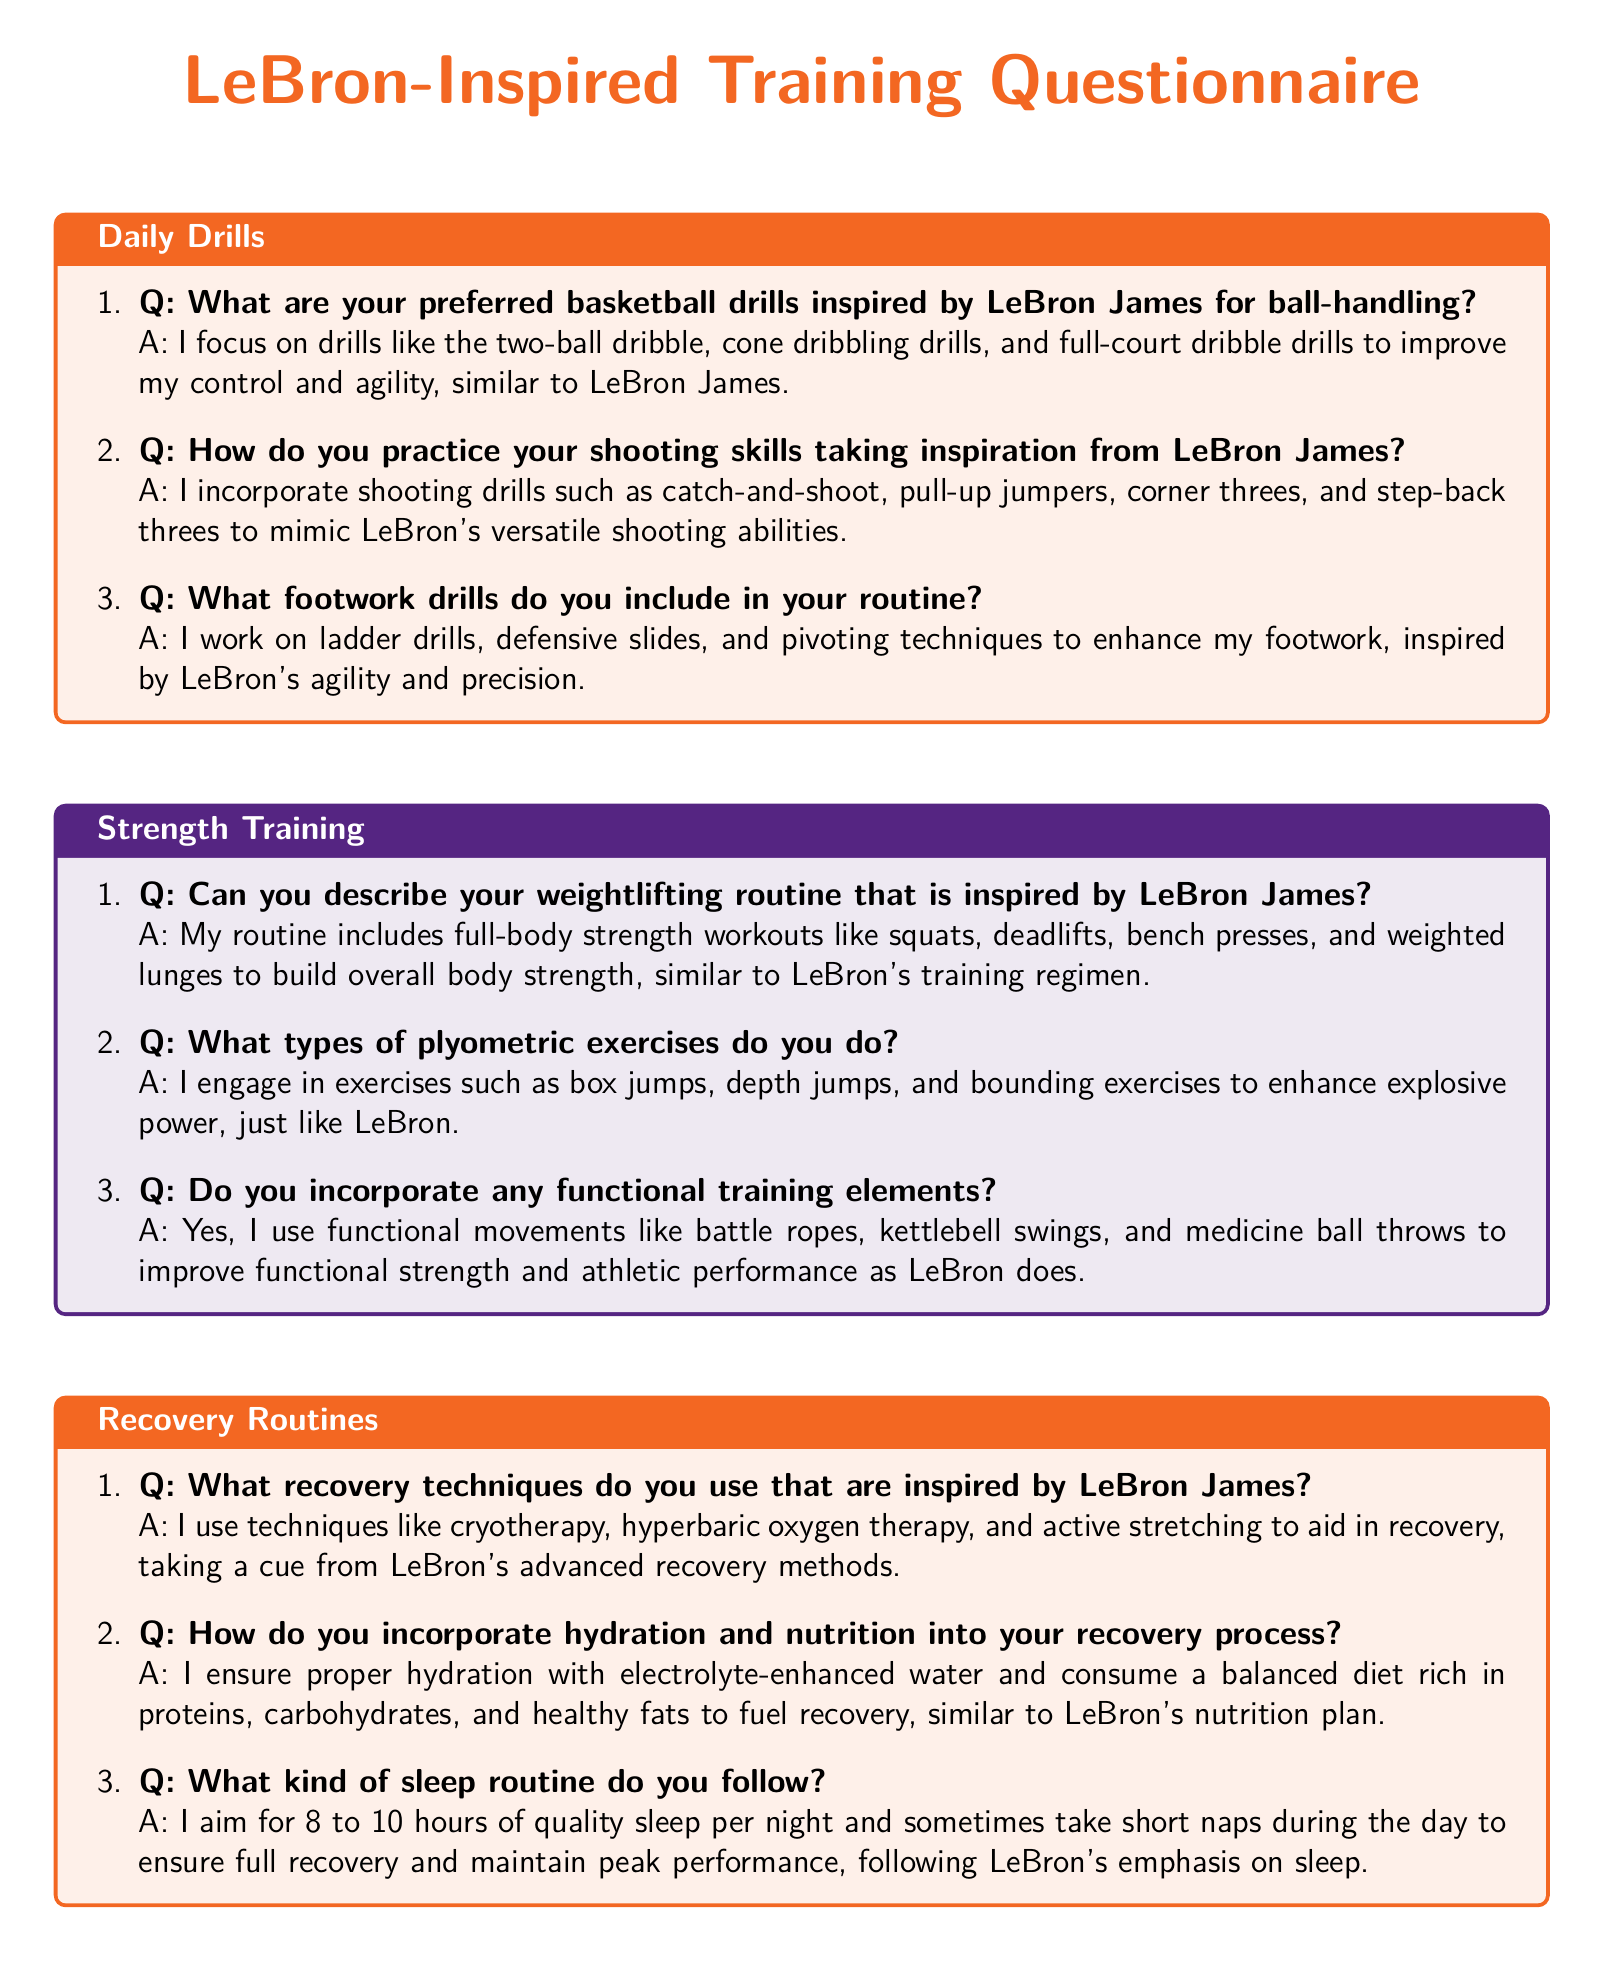What basketball drill is mentioned for ball-handling? The document lists preferred basketball drills inspired by LeBron James for ball-handling, which include the two-ball dribble.
Answer: two-ball dribble What type of workout is included in the strength training routine? The document describes a weightlifting routine that includes full-body strength workouts like squats.
Answer: squats What recovery method that aids in recovery is inspired by LeBron James? Among the recovery techniques mentioned in the document is cryotherapy, which helps with recovery.
Answer: cryotherapy How many hours of sleep do you aim for each night? The document specifies that you should aim for 8 to 10 hours of quality sleep per night for recovery.
Answer: 8 to 10 hours What element is included in the plyometric exercises? The document talks about engaging in exercises like box jumps as part of plyometric training inspired by LeBron.
Answer: box jumps Which type of hydration is mentioned in the recovery section? The document emphasizes proper hydration with electrolyte-enhanced water as part of the recovery process.
Answer: electrolyte-enhanced water What kind of drills are used to improve footwork? The document mentions that ladder drills are included to enhance footwork.
Answer: ladder drills 